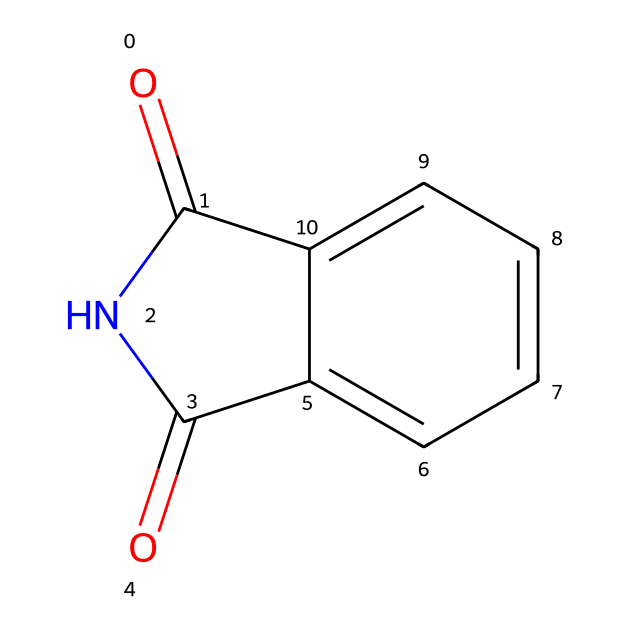What is the molecular formula of phthalimide? The structure shows two carbonyl groups (C=O) and one nitrogen atom (N) present in a bicyclic arrangement with twelve carbon atoms (C). Therefore, the molecular formula can be deduced as C8H5NO2.
Answer: C8H5NO2 How many rings are present in the phthalimide structure? Analyzing the structure reveals two fused rings, which are characteristic of the bicyclic nature of phthalimide.
Answer: two What functional groups are present in phthalimide? The structure contains two carbonyl groups (C=O) and a nitrogen atom incorporated in the cyclic structure, which are key functional groups in imides.
Answer: carbonyl and imide What is the number of carbon atoms in phthalimide? Counting the carbon atoms in the SMILES representation and the accompanying structure, there are a total of eight carbon atoms.
Answer: eight Why is phthalimide classified as an imide? The structure contains a nitrogen atom bonded between two carbonyl groups (C=O), fulfilling the defining characteristic of imides, which is the presence of a nitrogen atom adjacent to two carbonyl groups.
Answer: nitrogen adjacent to carbonyls How many hydrogen atoms are associated with the nitrogen in phthalimide? There are no hydrogen atoms directly bonded to the nitrogen in the structure, which indicates the nitrogen is sp2 hybridized and involved in the imide bond instead.
Answer: zero In what type of reactions is phthalimide commonly used as a precursor? Phthalimide is widely recognized as a precursor in synthetic routes, particularly for the production of various pharmaceutical compounds through nucleophilic substitution reactions involving the nitrogen atom.
Answer: pharmaceutical synthesis 